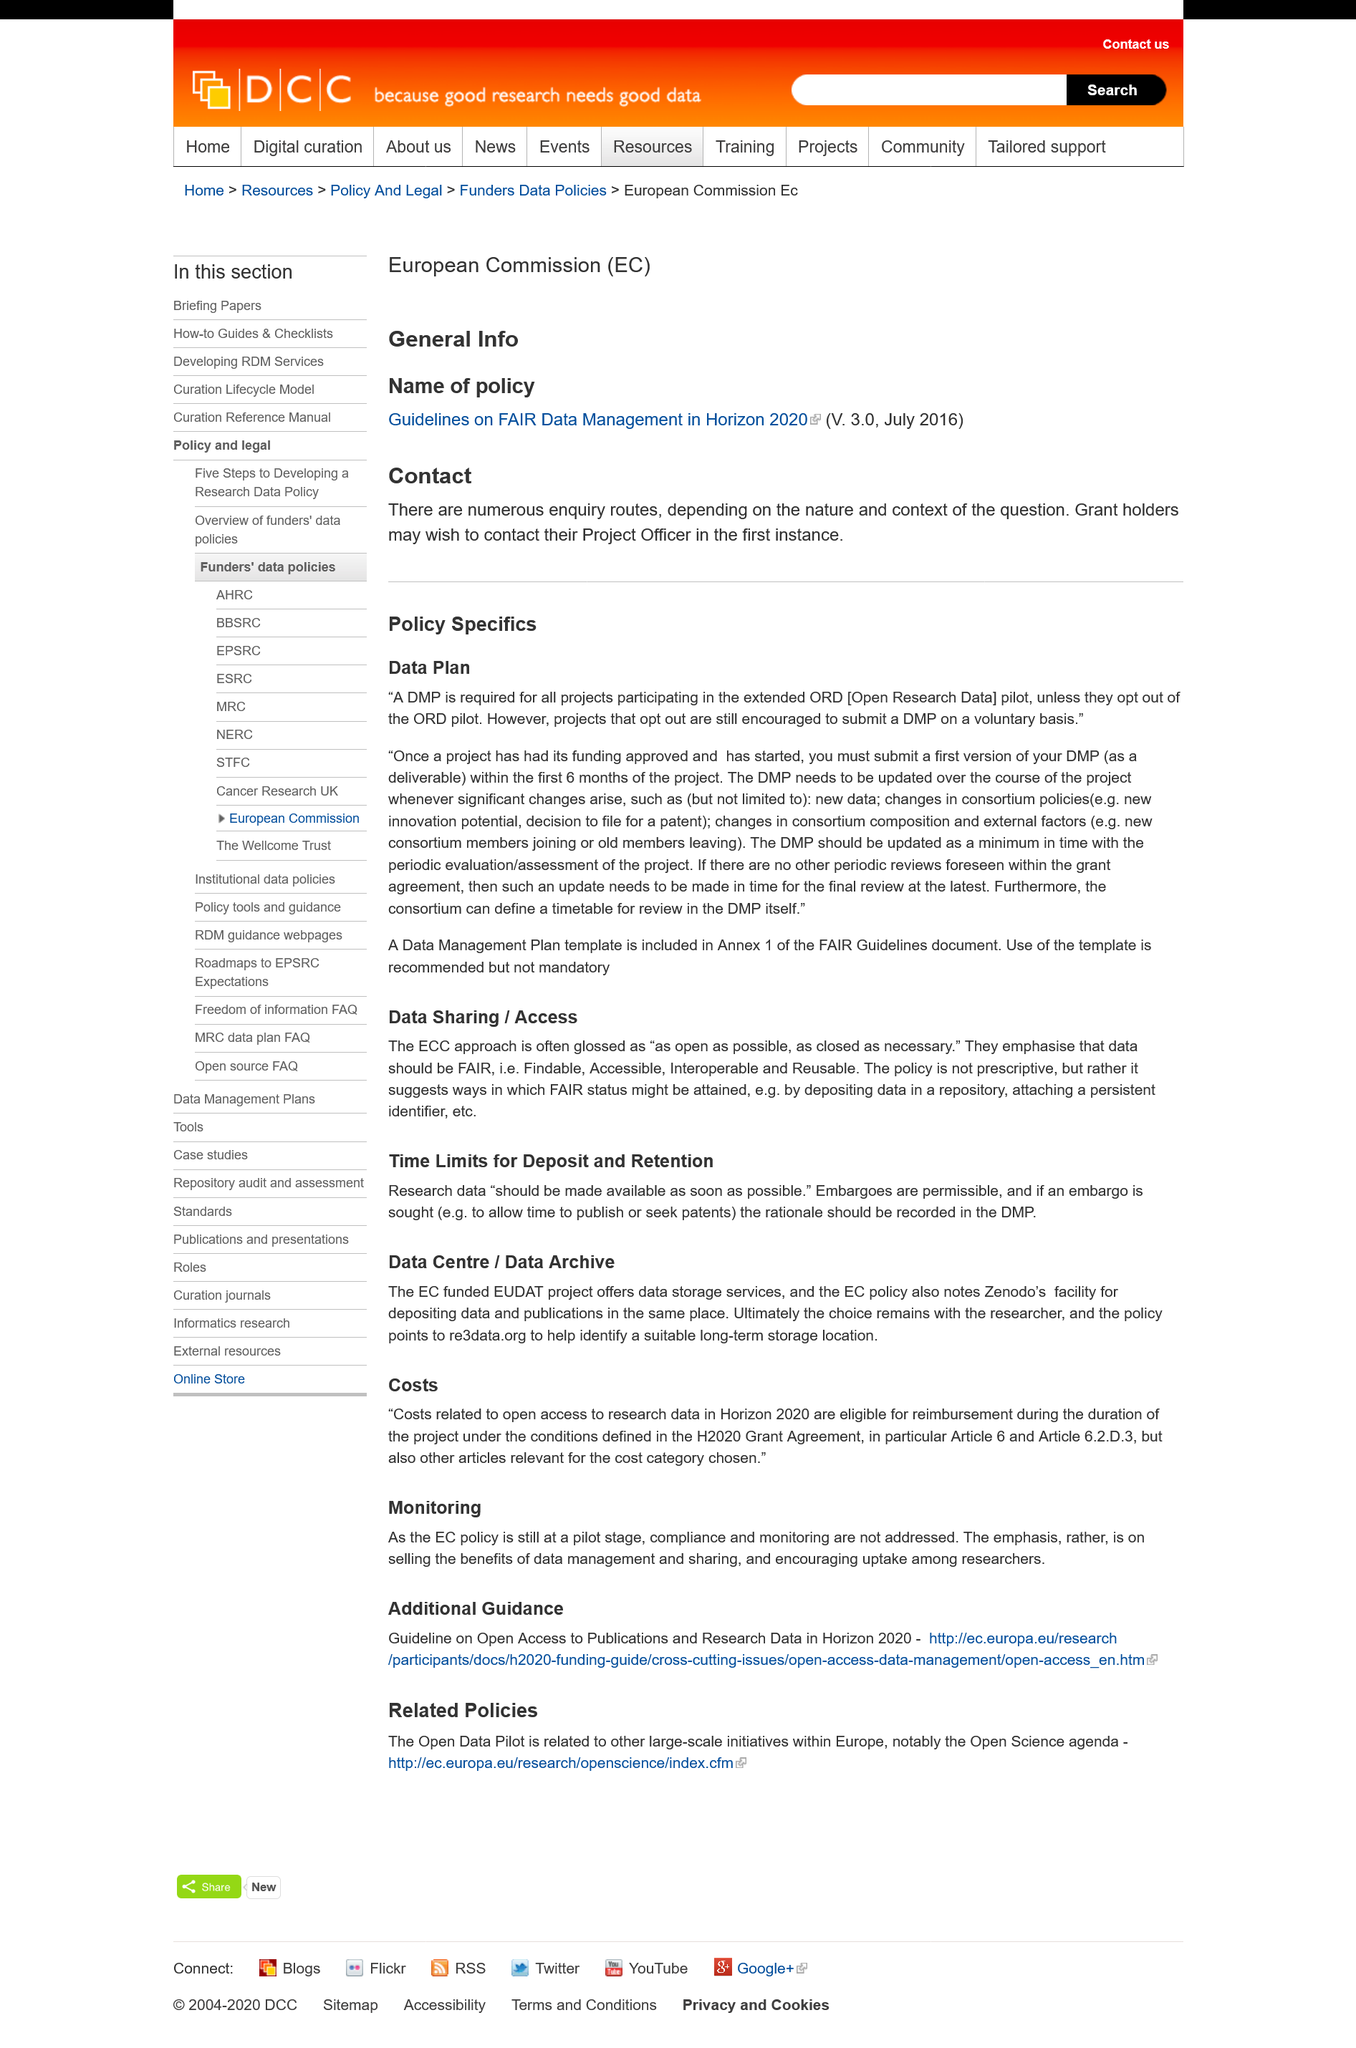Highlight a few significant elements in this photo. A Data Management Plan template is included in Annex 1 of the FAIR Guidelines document for the purpose of providing a guiding framework for managing data during the research process. A data plan is required for all projects participating in the extended ORD [Open Research Data] pilot, and a Data Management Plan (DMP) is required for all such projects. A Data Management Plan, commonly referred to as DMP, is a document that outlines the procedures and guidelines for managing data throughout a research project. It provides a framework for organizing, storing, and sharing research data in a way that ensures its quality, security, and accessibility, as well as compliance with relevant regulations and policies. DMPs are essential for ensuring the long-term preservation and reuse of research data, and they play a crucial role in promoting transparency, reproducibility, and collaboration in the research community. Research data should be made available as soon as possible, and any applicable time limits for its availability should be established to ensure its accessibility to those who need it for research purposes. The term "FAIR" data refers to data that is characterized by being Findable, Accessible, Interoperable, and Reusable. 